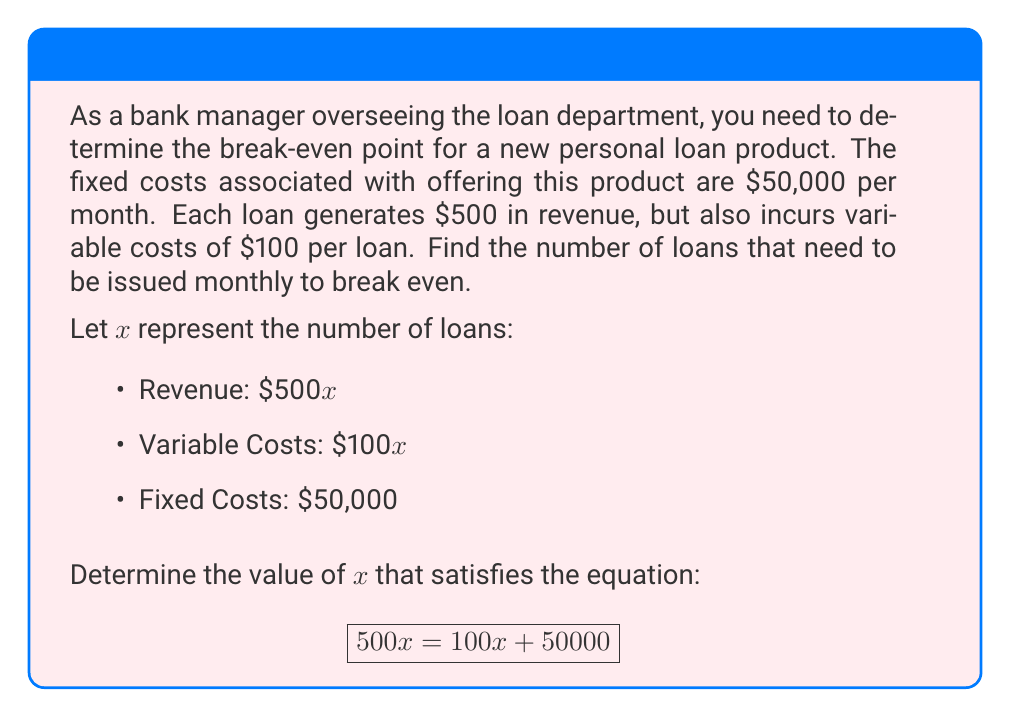Help me with this question. To find the break-even point, we need to solve the rational equation where revenue equals total costs (fixed + variable):

1) Set up the equation:
   $$500x = 100x + 50000$$

2) Subtract 100x from both sides to isolate the variable terms:
   $$400x = 50000$$

3) Divide both sides by 400 to solve for x:
   $$x = \frac{50000}{400}$$

4) Simplify the fraction:
   $$x = 125$$

Therefore, the bank needs to issue 125 loans per month to break even.

To verify:
Revenue: $500 * 125 = 62500$
Total Costs: $(100 * 125) + 50000 = 62500$

Revenue equals Total Costs, confirming the break-even point.
Answer: 125 loans 